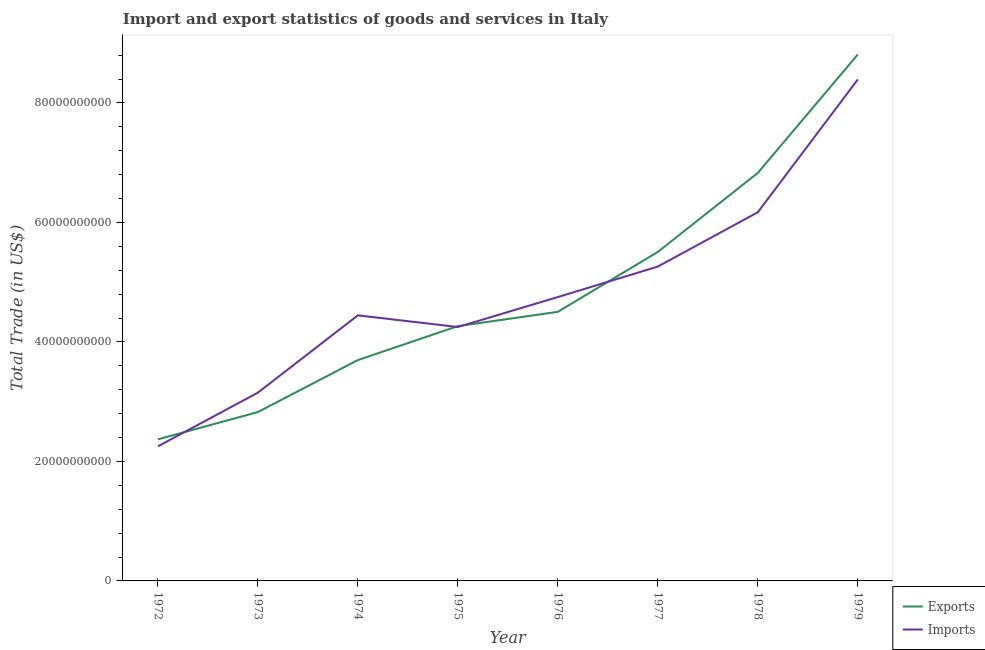Does the line corresponding to export of goods and services intersect with the line corresponding to imports of goods and services?
Your answer should be very brief. Yes. What is the imports of goods and services in 1976?
Offer a terse response. 4.75e+1. Across all years, what is the maximum imports of goods and services?
Provide a succinct answer. 8.39e+1. Across all years, what is the minimum imports of goods and services?
Ensure brevity in your answer.  2.25e+1. In which year was the imports of goods and services maximum?
Give a very brief answer. 1979. What is the total export of goods and services in the graph?
Your response must be concise. 3.88e+11. What is the difference between the imports of goods and services in 1972 and that in 1974?
Ensure brevity in your answer.  -2.19e+1. What is the difference between the imports of goods and services in 1972 and the export of goods and services in 1973?
Make the answer very short. -5.74e+09. What is the average imports of goods and services per year?
Provide a short and direct response. 4.83e+1. In the year 1972, what is the difference between the imports of goods and services and export of goods and services?
Your answer should be very brief. -1.17e+09. In how many years, is the imports of goods and services greater than 52000000000 US$?
Your answer should be very brief. 3. What is the ratio of the export of goods and services in 1978 to that in 1979?
Keep it short and to the point. 0.78. Is the export of goods and services in 1974 less than that in 1979?
Your answer should be very brief. Yes. What is the difference between the highest and the second highest imports of goods and services?
Offer a very short reply. 2.22e+1. What is the difference between the highest and the lowest export of goods and services?
Provide a short and direct response. 6.44e+1. In how many years, is the imports of goods and services greater than the average imports of goods and services taken over all years?
Offer a terse response. 3. Does the imports of goods and services monotonically increase over the years?
Your answer should be compact. No. Is the export of goods and services strictly less than the imports of goods and services over the years?
Offer a very short reply. No. How many lines are there?
Make the answer very short. 2. What is the difference between two consecutive major ticks on the Y-axis?
Offer a very short reply. 2.00e+1. Are the values on the major ticks of Y-axis written in scientific E-notation?
Your response must be concise. No. Does the graph contain any zero values?
Provide a succinct answer. No. Does the graph contain grids?
Offer a very short reply. No. Where does the legend appear in the graph?
Give a very brief answer. Bottom right. What is the title of the graph?
Your answer should be compact. Import and export statistics of goods and services in Italy. Does "IMF concessional" appear as one of the legend labels in the graph?
Your answer should be compact. No. What is the label or title of the X-axis?
Your answer should be compact. Year. What is the label or title of the Y-axis?
Keep it short and to the point. Total Trade (in US$). What is the Total Trade (in US$) of Exports in 1972?
Keep it short and to the point. 2.37e+1. What is the Total Trade (in US$) of Imports in 1972?
Provide a short and direct response. 2.25e+1. What is the Total Trade (in US$) in Exports in 1973?
Make the answer very short. 2.83e+1. What is the Total Trade (in US$) of Imports in 1973?
Offer a terse response. 3.15e+1. What is the Total Trade (in US$) in Exports in 1974?
Your answer should be very brief. 3.70e+1. What is the Total Trade (in US$) of Imports in 1974?
Provide a short and direct response. 4.44e+1. What is the Total Trade (in US$) of Exports in 1975?
Provide a succinct answer. 4.26e+1. What is the Total Trade (in US$) in Imports in 1975?
Keep it short and to the point. 4.25e+1. What is the Total Trade (in US$) in Exports in 1976?
Your answer should be very brief. 4.50e+1. What is the Total Trade (in US$) in Imports in 1976?
Your answer should be very brief. 4.75e+1. What is the Total Trade (in US$) in Exports in 1977?
Give a very brief answer. 5.51e+1. What is the Total Trade (in US$) of Imports in 1977?
Your answer should be very brief. 5.26e+1. What is the Total Trade (in US$) of Exports in 1978?
Provide a succinct answer. 6.83e+1. What is the Total Trade (in US$) of Imports in 1978?
Ensure brevity in your answer.  6.17e+1. What is the Total Trade (in US$) of Exports in 1979?
Keep it short and to the point. 8.81e+1. What is the Total Trade (in US$) in Imports in 1979?
Offer a terse response. 8.39e+1. Across all years, what is the maximum Total Trade (in US$) in Exports?
Your response must be concise. 8.81e+1. Across all years, what is the maximum Total Trade (in US$) of Imports?
Ensure brevity in your answer.  8.39e+1. Across all years, what is the minimum Total Trade (in US$) in Exports?
Ensure brevity in your answer.  2.37e+1. Across all years, what is the minimum Total Trade (in US$) in Imports?
Give a very brief answer. 2.25e+1. What is the total Total Trade (in US$) of Exports in the graph?
Give a very brief answer. 3.88e+11. What is the total Total Trade (in US$) in Imports in the graph?
Offer a terse response. 3.87e+11. What is the difference between the Total Trade (in US$) in Exports in 1972 and that in 1973?
Give a very brief answer. -4.57e+09. What is the difference between the Total Trade (in US$) in Imports in 1972 and that in 1973?
Provide a succinct answer. -8.99e+09. What is the difference between the Total Trade (in US$) in Exports in 1972 and that in 1974?
Ensure brevity in your answer.  -1.33e+1. What is the difference between the Total Trade (in US$) of Imports in 1972 and that in 1974?
Your answer should be very brief. -2.19e+1. What is the difference between the Total Trade (in US$) in Exports in 1972 and that in 1975?
Offer a very short reply. -1.90e+1. What is the difference between the Total Trade (in US$) in Imports in 1972 and that in 1975?
Offer a very short reply. -2.00e+1. What is the difference between the Total Trade (in US$) of Exports in 1972 and that in 1976?
Your response must be concise. -2.13e+1. What is the difference between the Total Trade (in US$) of Imports in 1972 and that in 1976?
Your answer should be very brief. -2.50e+1. What is the difference between the Total Trade (in US$) in Exports in 1972 and that in 1977?
Provide a succinct answer. -3.14e+1. What is the difference between the Total Trade (in US$) in Imports in 1972 and that in 1977?
Keep it short and to the point. -3.01e+1. What is the difference between the Total Trade (in US$) of Exports in 1972 and that in 1978?
Provide a short and direct response. -4.46e+1. What is the difference between the Total Trade (in US$) in Imports in 1972 and that in 1978?
Provide a succinct answer. -3.92e+1. What is the difference between the Total Trade (in US$) in Exports in 1972 and that in 1979?
Give a very brief answer. -6.44e+1. What is the difference between the Total Trade (in US$) in Imports in 1972 and that in 1979?
Your response must be concise. -6.14e+1. What is the difference between the Total Trade (in US$) of Exports in 1973 and that in 1974?
Ensure brevity in your answer.  -8.70e+09. What is the difference between the Total Trade (in US$) of Imports in 1973 and that in 1974?
Give a very brief answer. -1.29e+1. What is the difference between the Total Trade (in US$) in Exports in 1973 and that in 1975?
Provide a succinct answer. -1.44e+1. What is the difference between the Total Trade (in US$) of Imports in 1973 and that in 1975?
Make the answer very short. -1.10e+1. What is the difference between the Total Trade (in US$) of Exports in 1973 and that in 1976?
Keep it short and to the point. -1.68e+1. What is the difference between the Total Trade (in US$) in Imports in 1973 and that in 1976?
Offer a terse response. -1.60e+1. What is the difference between the Total Trade (in US$) of Exports in 1973 and that in 1977?
Your answer should be compact. -2.68e+1. What is the difference between the Total Trade (in US$) in Imports in 1973 and that in 1977?
Make the answer very short. -2.11e+1. What is the difference between the Total Trade (in US$) of Exports in 1973 and that in 1978?
Ensure brevity in your answer.  -4.00e+1. What is the difference between the Total Trade (in US$) in Imports in 1973 and that in 1978?
Your answer should be compact. -3.02e+1. What is the difference between the Total Trade (in US$) in Exports in 1973 and that in 1979?
Give a very brief answer. -5.99e+1. What is the difference between the Total Trade (in US$) of Imports in 1973 and that in 1979?
Keep it short and to the point. -5.24e+1. What is the difference between the Total Trade (in US$) of Exports in 1974 and that in 1975?
Your response must be concise. -5.68e+09. What is the difference between the Total Trade (in US$) of Imports in 1974 and that in 1975?
Offer a terse response. 1.95e+09. What is the difference between the Total Trade (in US$) in Exports in 1974 and that in 1976?
Ensure brevity in your answer.  -8.08e+09. What is the difference between the Total Trade (in US$) of Imports in 1974 and that in 1976?
Your response must be concise. -3.06e+09. What is the difference between the Total Trade (in US$) of Exports in 1974 and that in 1977?
Your answer should be very brief. -1.81e+1. What is the difference between the Total Trade (in US$) in Imports in 1974 and that in 1977?
Keep it short and to the point. -8.16e+09. What is the difference between the Total Trade (in US$) in Exports in 1974 and that in 1978?
Offer a very short reply. -3.13e+1. What is the difference between the Total Trade (in US$) of Imports in 1974 and that in 1978?
Your answer should be compact. -1.73e+1. What is the difference between the Total Trade (in US$) in Exports in 1974 and that in 1979?
Ensure brevity in your answer.  -5.11e+1. What is the difference between the Total Trade (in US$) of Imports in 1974 and that in 1979?
Make the answer very short. -3.95e+1. What is the difference between the Total Trade (in US$) in Exports in 1975 and that in 1976?
Your answer should be compact. -2.39e+09. What is the difference between the Total Trade (in US$) in Imports in 1975 and that in 1976?
Your response must be concise. -5.01e+09. What is the difference between the Total Trade (in US$) of Exports in 1975 and that in 1977?
Keep it short and to the point. -1.24e+1. What is the difference between the Total Trade (in US$) in Imports in 1975 and that in 1977?
Make the answer very short. -1.01e+1. What is the difference between the Total Trade (in US$) in Exports in 1975 and that in 1978?
Make the answer very short. -2.56e+1. What is the difference between the Total Trade (in US$) of Imports in 1975 and that in 1978?
Make the answer very short. -1.92e+1. What is the difference between the Total Trade (in US$) of Exports in 1975 and that in 1979?
Offer a terse response. -4.55e+1. What is the difference between the Total Trade (in US$) of Imports in 1975 and that in 1979?
Ensure brevity in your answer.  -4.14e+1. What is the difference between the Total Trade (in US$) of Exports in 1976 and that in 1977?
Your response must be concise. -1.00e+1. What is the difference between the Total Trade (in US$) of Imports in 1976 and that in 1977?
Your answer should be very brief. -5.10e+09. What is the difference between the Total Trade (in US$) in Exports in 1976 and that in 1978?
Your response must be concise. -2.33e+1. What is the difference between the Total Trade (in US$) in Imports in 1976 and that in 1978?
Make the answer very short. -1.42e+1. What is the difference between the Total Trade (in US$) in Exports in 1976 and that in 1979?
Keep it short and to the point. -4.31e+1. What is the difference between the Total Trade (in US$) in Imports in 1976 and that in 1979?
Ensure brevity in your answer.  -3.64e+1. What is the difference between the Total Trade (in US$) in Exports in 1977 and that in 1978?
Provide a succinct answer. -1.32e+1. What is the difference between the Total Trade (in US$) of Imports in 1977 and that in 1978?
Your answer should be compact. -9.09e+09. What is the difference between the Total Trade (in US$) in Exports in 1977 and that in 1979?
Keep it short and to the point. -3.30e+1. What is the difference between the Total Trade (in US$) in Imports in 1977 and that in 1979?
Your answer should be compact. -3.13e+1. What is the difference between the Total Trade (in US$) of Exports in 1978 and that in 1979?
Provide a short and direct response. -1.98e+1. What is the difference between the Total Trade (in US$) of Imports in 1978 and that in 1979?
Your response must be concise. -2.22e+1. What is the difference between the Total Trade (in US$) in Exports in 1972 and the Total Trade (in US$) in Imports in 1973?
Your answer should be very brief. -7.82e+09. What is the difference between the Total Trade (in US$) in Exports in 1972 and the Total Trade (in US$) in Imports in 1974?
Provide a short and direct response. -2.08e+1. What is the difference between the Total Trade (in US$) in Exports in 1972 and the Total Trade (in US$) in Imports in 1975?
Make the answer very short. -1.88e+1. What is the difference between the Total Trade (in US$) in Exports in 1972 and the Total Trade (in US$) in Imports in 1976?
Your answer should be compact. -2.38e+1. What is the difference between the Total Trade (in US$) in Exports in 1972 and the Total Trade (in US$) in Imports in 1977?
Provide a succinct answer. -2.89e+1. What is the difference between the Total Trade (in US$) in Exports in 1972 and the Total Trade (in US$) in Imports in 1978?
Provide a succinct answer. -3.80e+1. What is the difference between the Total Trade (in US$) of Exports in 1972 and the Total Trade (in US$) of Imports in 1979?
Provide a short and direct response. -6.02e+1. What is the difference between the Total Trade (in US$) in Exports in 1973 and the Total Trade (in US$) in Imports in 1974?
Ensure brevity in your answer.  -1.62e+1. What is the difference between the Total Trade (in US$) of Exports in 1973 and the Total Trade (in US$) of Imports in 1975?
Provide a short and direct response. -1.42e+1. What is the difference between the Total Trade (in US$) of Exports in 1973 and the Total Trade (in US$) of Imports in 1976?
Offer a very short reply. -1.92e+1. What is the difference between the Total Trade (in US$) of Exports in 1973 and the Total Trade (in US$) of Imports in 1977?
Your answer should be compact. -2.44e+1. What is the difference between the Total Trade (in US$) of Exports in 1973 and the Total Trade (in US$) of Imports in 1978?
Provide a short and direct response. -3.34e+1. What is the difference between the Total Trade (in US$) of Exports in 1973 and the Total Trade (in US$) of Imports in 1979?
Your answer should be very brief. -5.57e+1. What is the difference between the Total Trade (in US$) of Exports in 1974 and the Total Trade (in US$) of Imports in 1975?
Keep it short and to the point. -5.53e+09. What is the difference between the Total Trade (in US$) of Exports in 1974 and the Total Trade (in US$) of Imports in 1976?
Make the answer very short. -1.05e+1. What is the difference between the Total Trade (in US$) in Exports in 1974 and the Total Trade (in US$) in Imports in 1977?
Give a very brief answer. -1.57e+1. What is the difference between the Total Trade (in US$) of Exports in 1974 and the Total Trade (in US$) of Imports in 1978?
Ensure brevity in your answer.  -2.47e+1. What is the difference between the Total Trade (in US$) of Exports in 1974 and the Total Trade (in US$) of Imports in 1979?
Provide a short and direct response. -4.70e+1. What is the difference between the Total Trade (in US$) in Exports in 1975 and the Total Trade (in US$) in Imports in 1976?
Your answer should be compact. -4.86e+09. What is the difference between the Total Trade (in US$) of Exports in 1975 and the Total Trade (in US$) of Imports in 1977?
Keep it short and to the point. -9.97e+09. What is the difference between the Total Trade (in US$) in Exports in 1975 and the Total Trade (in US$) in Imports in 1978?
Provide a succinct answer. -1.91e+1. What is the difference between the Total Trade (in US$) of Exports in 1975 and the Total Trade (in US$) of Imports in 1979?
Your answer should be compact. -4.13e+1. What is the difference between the Total Trade (in US$) in Exports in 1976 and the Total Trade (in US$) in Imports in 1977?
Keep it short and to the point. -7.58e+09. What is the difference between the Total Trade (in US$) of Exports in 1976 and the Total Trade (in US$) of Imports in 1978?
Provide a short and direct response. -1.67e+1. What is the difference between the Total Trade (in US$) of Exports in 1976 and the Total Trade (in US$) of Imports in 1979?
Your answer should be compact. -3.89e+1. What is the difference between the Total Trade (in US$) in Exports in 1977 and the Total Trade (in US$) in Imports in 1978?
Keep it short and to the point. -6.64e+09. What is the difference between the Total Trade (in US$) of Exports in 1977 and the Total Trade (in US$) of Imports in 1979?
Offer a very short reply. -2.89e+1. What is the difference between the Total Trade (in US$) in Exports in 1978 and the Total Trade (in US$) in Imports in 1979?
Make the answer very short. -1.56e+1. What is the average Total Trade (in US$) in Exports per year?
Your response must be concise. 4.85e+1. What is the average Total Trade (in US$) in Imports per year?
Provide a short and direct response. 4.83e+1. In the year 1972, what is the difference between the Total Trade (in US$) of Exports and Total Trade (in US$) of Imports?
Provide a succinct answer. 1.17e+09. In the year 1973, what is the difference between the Total Trade (in US$) of Exports and Total Trade (in US$) of Imports?
Make the answer very short. -3.25e+09. In the year 1974, what is the difference between the Total Trade (in US$) of Exports and Total Trade (in US$) of Imports?
Provide a short and direct response. -7.49e+09. In the year 1975, what is the difference between the Total Trade (in US$) of Exports and Total Trade (in US$) of Imports?
Provide a short and direct response. 1.50e+08. In the year 1976, what is the difference between the Total Trade (in US$) in Exports and Total Trade (in US$) in Imports?
Ensure brevity in your answer.  -2.47e+09. In the year 1977, what is the difference between the Total Trade (in US$) in Exports and Total Trade (in US$) in Imports?
Your answer should be very brief. 2.45e+09. In the year 1978, what is the difference between the Total Trade (in US$) of Exports and Total Trade (in US$) of Imports?
Offer a terse response. 6.59e+09. In the year 1979, what is the difference between the Total Trade (in US$) in Exports and Total Trade (in US$) in Imports?
Provide a succinct answer. 4.18e+09. What is the ratio of the Total Trade (in US$) in Exports in 1972 to that in 1973?
Provide a short and direct response. 0.84. What is the ratio of the Total Trade (in US$) in Imports in 1972 to that in 1973?
Provide a short and direct response. 0.71. What is the ratio of the Total Trade (in US$) in Exports in 1972 to that in 1974?
Offer a terse response. 0.64. What is the ratio of the Total Trade (in US$) of Imports in 1972 to that in 1974?
Your answer should be very brief. 0.51. What is the ratio of the Total Trade (in US$) in Exports in 1972 to that in 1975?
Your answer should be very brief. 0.56. What is the ratio of the Total Trade (in US$) in Imports in 1972 to that in 1975?
Keep it short and to the point. 0.53. What is the ratio of the Total Trade (in US$) of Exports in 1972 to that in 1976?
Ensure brevity in your answer.  0.53. What is the ratio of the Total Trade (in US$) in Imports in 1972 to that in 1976?
Keep it short and to the point. 0.47. What is the ratio of the Total Trade (in US$) in Exports in 1972 to that in 1977?
Keep it short and to the point. 0.43. What is the ratio of the Total Trade (in US$) of Imports in 1972 to that in 1977?
Ensure brevity in your answer.  0.43. What is the ratio of the Total Trade (in US$) of Exports in 1972 to that in 1978?
Your response must be concise. 0.35. What is the ratio of the Total Trade (in US$) of Imports in 1972 to that in 1978?
Ensure brevity in your answer.  0.36. What is the ratio of the Total Trade (in US$) in Exports in 1972 to that in 1979?
Offer a very short reply. 0.27. What is the ratio of the Total Trade (in US$) of Imports in 1972 to that in 1979?
Make the answer very short. 0.27. What is the ratio of the Total Trade (in US$) of Exports in 1973 to that in 1974?
Offer a very short reply. 0.76. What is the ratio of the Total Trade (in US$) in Imports in 1973 to that in 1974?
Make the answer very short. 0.71. What is the ratio of the Total Trade (in US$) in Exports in 1973 to that in 1975?
Give a very brief answer. 0.66. What is the ratio of the Total Trade (in US$) in Imports in 1973 to that in 1975?
Your answer should be very brief. 0.74. What is the ratio of the Total Trade (in US$) of Exports in 1973 to that in 1976?
Keep it short and to the point. 0.63. What is the ratio of the Total Trade (in US$) of Imports in 1973 to that in 1976?
Provide a short and direct response. 0.66. What is the ratio of the Total Trade (in US$) in Exports in 1973 to that in 1977?
Provide a succinct answer. 0.51. What is the ratio of the Total Trade (in US$) in Imports in 1973 to that in 1977?
Your response must be concise. 0.6. What is the ratio of the Total Trade (in US$) in Exports in 1973 to that in 1978?
Offer a terse response. 0.41. What is the ratio of the Total Trade (in US$) of Imports in 1973 to that in 1978?
Your answer should be compact. 0.51. What is the ratio of the Total Trade (in US$) of Exports in 1973 to that in 1979?
Provide a short and direct response. 0.32. What is the ratio of the Total Trade (in US$) in Imports in 1973 to that in 1979?
Offer a very short reply. 0.38. What is the ratio of the Total Trade (in US$) in Exports in 1974 to that in 1975?
Offer a terse response. 0.87. What is the ratio of the Total Trade (in US$) in Imports in 1974 to that in 1975?
Your answer should be very brief. 1.05. What is the ratio of the Total Trade (in US$) in Exports in 1974 to that in 1976?
Offer a very short reply. 0.82. What is the ratio of the Total Trade (in US$) of Imports in 1974 to that in 1976?
Make the answer very short. 0.94. What is the ratio of the Total Trade (in US$) in Exports in 1974 to that in 1977?
Your answer should be very brief. 0.67. What is the ratio of the Total Trade (in US$) of Imports in 1974 to that in 1977?
Offer a very short reply. 0.84. What is the ratio of the Total Trade (in US$) of Exports in 1974 to that in 1978?
Make the answer very short. 0.54. What is the ratio of the Total Trade (in US$) in Imports in 1974 to that in 1978?
Offer a terse response. 0.72. What is the ratio of the Total Trade (in US$) of Exports in 1974 to that in 1979?
Offer a very short reply. 0.42. What is the ratio of the Total Trade (in US$) of Imports in 1974 to that in 1979?
Offer a very short reply. 0.53. What is the ratio of the Total Trade (in US$) in Exports in 1975 to that in 1976?
Keep it short and to the point. 0.95. What is the ratio of the Total Trade (in US$) in Imports in 1975 to that in 1976?
Provide a succinct answer. 0.89. What is the ratio of the Total Trade (in US$) in Exports in 1975 to that in 1977?
Your answer should be compact. 0.77. What is the ratio of the Total Trade (in US$) of Imports in 1975 to that in 1977?
Your answer should be compact. 0.81. What is the ratio of the Total Trade (in US$) in Exports in 1975 to that in 1978?
Offer a terse response. 0.62. What is the ratio of the Total Trade (in US$) of Imports in 1975 to that in 1978?
Make the answer very short. 0.69. What is the ratio of the Total Trade (in US$) of Exports in 1975 to that in 1979?
Provide a short and direct response. 0.48. What is the ratio of the Total Trade (in US$) in Imports in 1975 to that in 1979?
Your answer should be very brief. 0.51. What is the ratio of the Total Trade (in US$) of Exports in 1976 to that in 1977?
Ensure brevity in your answer.  0.82. What is the ratio of the Total Trade (in US$) of Imports in 1976 to that in 1977?
Your answer should be compact. 0.9. What is the ratio of the Total Trade (in US$) of Exports in 1976 to that in 1978?
Offer a terse response. 0.66. What is the ratio of the Total Trade (in US$) in Imports in 1976 to that in 1978?
Offer a very short reply. 0.77. What is the ratio of the Total Trade (in US$) in Exports in 1976 to that in 1979?
Provide a succinct answer. 0.51. What is the ratio of the Total Trade (in US$) in Imports in 1976 to that in 1979?
Your response must be concise. 0.57. What is the ratio of the Total Trade (in US$) in Exports in 1977 to that in 1978?
Make the answer very short. 0.81. What is the ratio of the Total Trade (in US$) of Imports in 1977 to that in 1978?
Ensure brevity in your answer.  0.85. What is the ratio of the Total Trade (in US$) in Exports in 1977 to that in 1979?
Offer a very short reply. 0.62. What is the ratio of the Total Trade (in US$) in Imports in 1977 to that in 1979?
Offer a very short reply. 0.63. What is the ratio of the Total Trade (in US$) in Exports in 1978 to that in 1979?
Your answer should be very brief. 0.78. What is the ratio of the Total Trade (in US$) of Imports in 1978 to that in 1979?
Offer a terse response. 0.74. What is the difference between the highest and the second highest Total Trade (in US$) of Exports?
Your response must be concise. 1.98e+1. What is the difference between the highest and the second highest Total Trade (in US$) in Imports?
Provide a succinct answer. 2.22e+1. What is the difference between the highest and the lowest Total Trade (in US$) in Exports?
Your answer should be compact. 6.44e+1. What is the difference between the highest and the lowest Total Trade (in US$) of Imports?
Offer a terse response. 6.14e+1. 